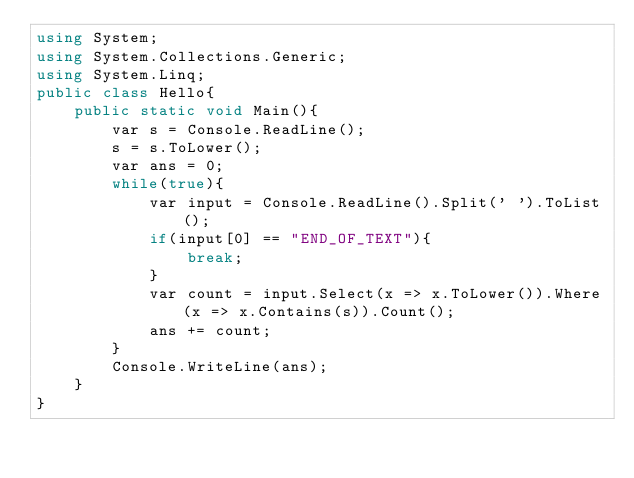Convert code to text. <code><loc_0><loc_0><loc_500><loc_500><_C#_>using System;
using System.Collections.Generic;
using System.Linq;
public class Hello{
    public static void Main(){
        var s = Console.ReadLine();
        s = s.ToLower();
        var ans = 0;
        while(true){
            var input = Console.ReadLine().Split(' ').ToList();
            if(input[0] == "END_OF_TEXT"){
                break;
            }
            var count = input.Select(x => x.ToLower()).Where(x => x.Contains(s)).Count();
            ans += count;
        }
        Console.WriteLine(ans);
    }
}

</code> 